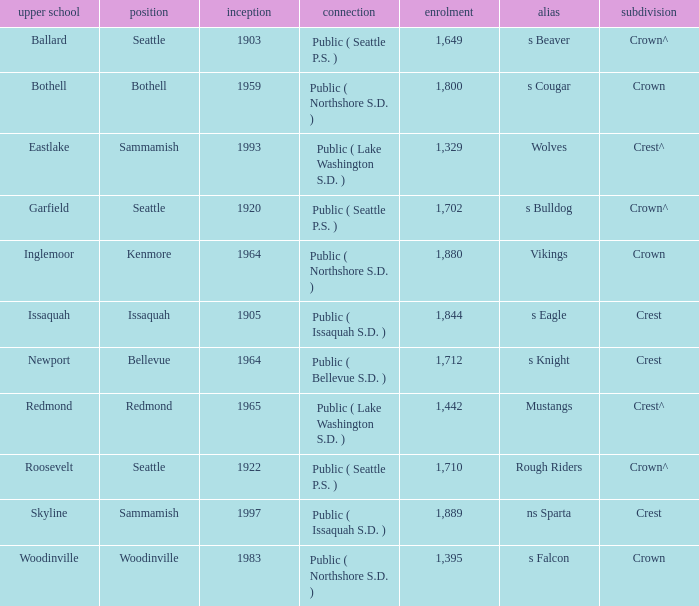What is the affiliation of a high school in Issaquah that was founded in less than 1965? Public ( Issaquah S.D. ). 